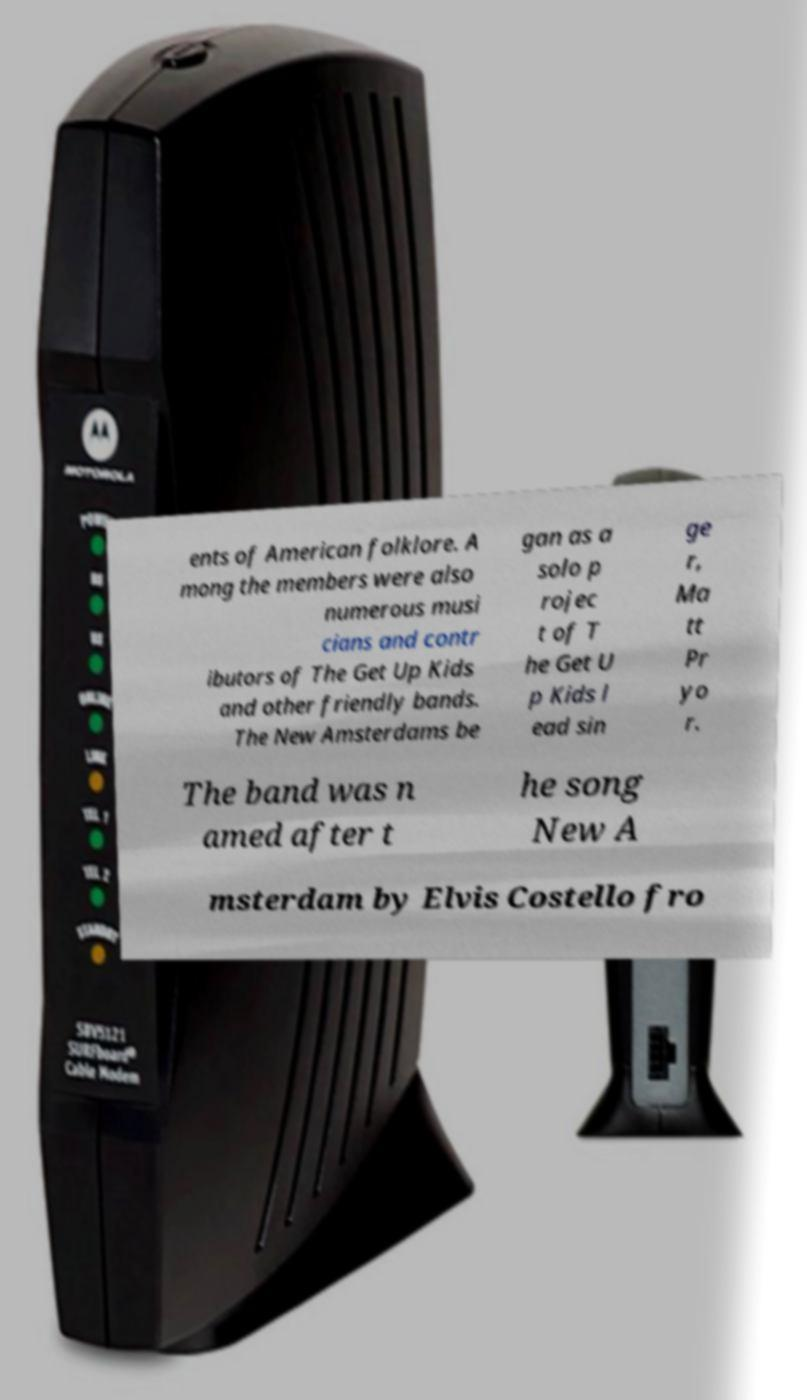Can you accurately transcribe the text from the provided image for me? ents of American folklore. A mong the members were also numerous musi cians and contr ibutors of The Get Up Kids and other friendly bands. The New Amsterdams be gan as a solo p rojec t of T he Get U p Kids l ead sin ge r, Ma tt Pr yo r. The band was n amed after t he song New A msterdam by Elvis Costello fro 